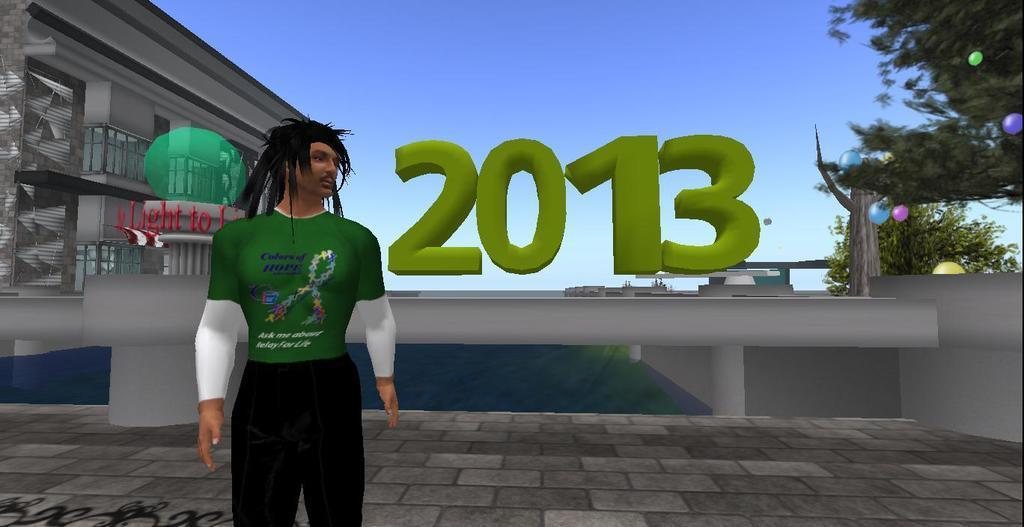Could you give a brief overview of what you see in this image? In this picture there is a animated gaming photograph of a man wearing a green color t-shirt and black jeans. Behind 2013 is written and on the left side we can see the building and trees. 